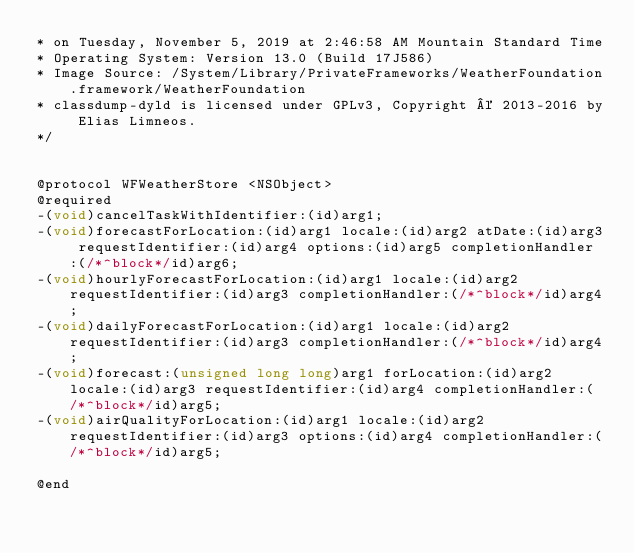<code> <loc_0><loc_0><loc_500><loc_500><_C_>* on Tuesday, November 5, 2019 at 2:46:58 AM Mountain Standard Time
* Operating System: Version 13.0 (Build 17J586)
* Image Source: /System/Library/PrivateFrameworks/WeatherFoundation.framework/WeatherFoundation
* classdump-dyld is licensed under GPLv3, Copyright © 2013-2016 by Elias Limneos.
*/


@protocol WFWeatherStore <NSObject>
@required
-(void)cancelTaskWithIdentifier:(id)arg1;
-(void)forecastForLocation:(id)arg1 locale:(id)arg2 atDate:(id)arg3 requestIdentifier:(id)arg4 options:(id)arg5 completionHandler:(/*^block*/id)arg6;
-(void)hourlyForecastForLocation:(id)arg1 locale:(id)arg2 requestIdentifier:(id)arg3 completionHandler:(/*^block*/id)arg4;
-(void)dailyForecastForLocation:(id)arg1 locale:(id)arg2 requestIdentifier:(id)arg3 completionHandler:(/*^block*/id)arg4;
-(void)forecast:(unsigned long long)arg1 forLocation:(id)arg2 locale:(id)arg3 requestIdentifier:(id)arg4 completionHandler:(/*^block*/id)arg5;
-(void)airQualityForLocation:(id)arg1 locale:(id)arg2 requestIdentifier:(id)arg3 options:(id)arg4 completionHandler:(/*^block*/id)arg5;

@end

</code> 